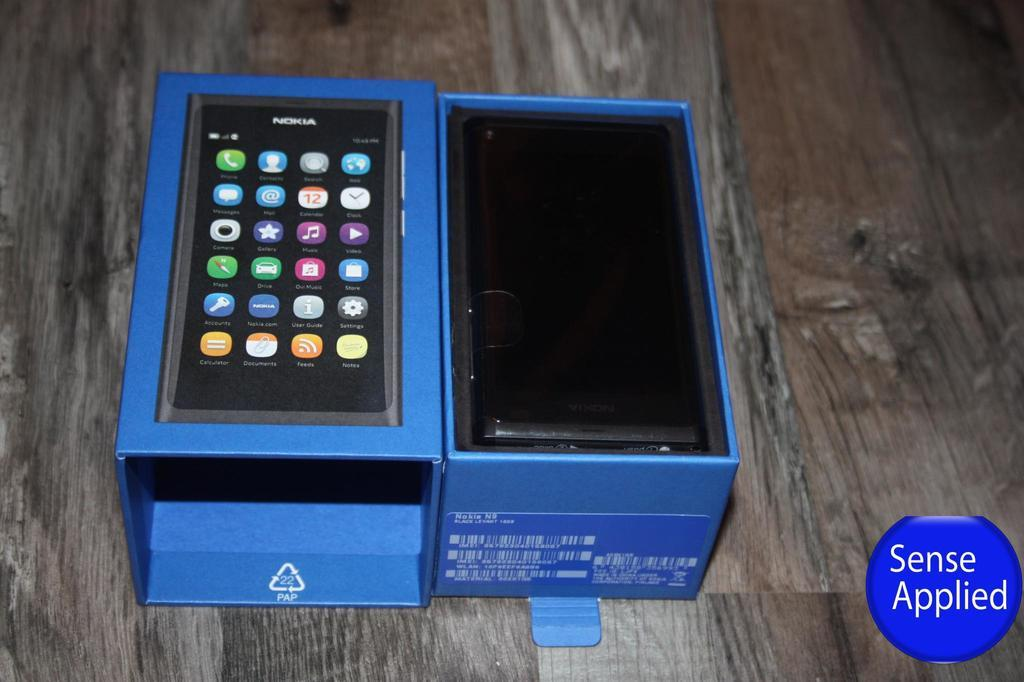<image>
Provide a brief description of the given image. The black nokia phone sits in a blue phone box. 